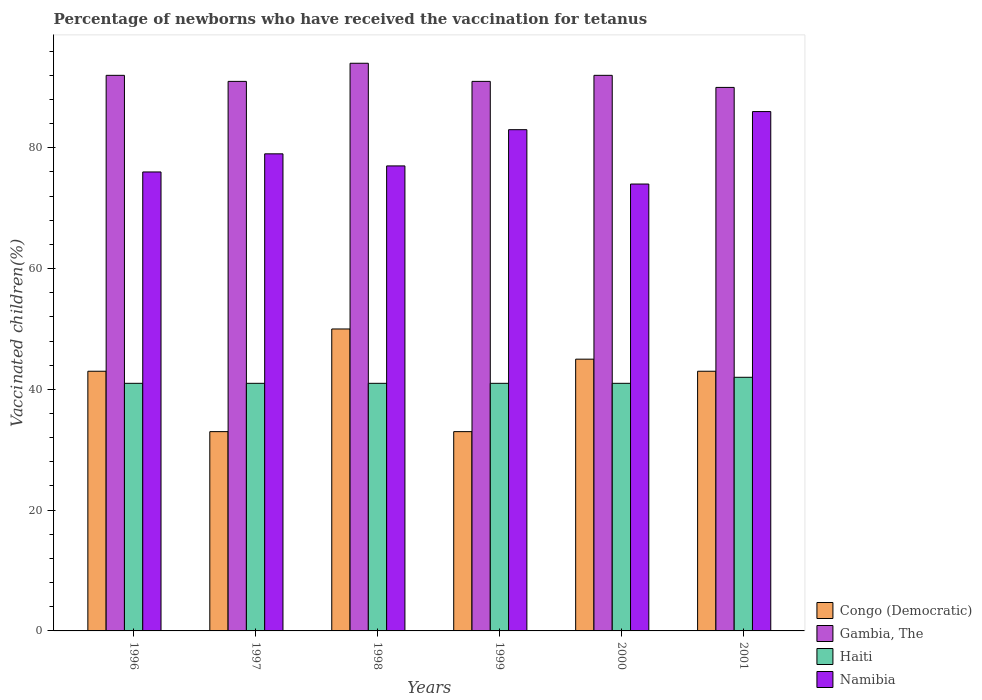How many different coloured bars are there?
Provide a short and direct response. 4. How many groups of bars are there?
Your answer should be compact. 6. What is the percentage of vaccinated children in Haiti in 1996?
Keep it short and to the point. 41. Across all years, what is the maximum percentage of vaccinated children in Haiti?
Make the answer very short. 42. Across all years, what is the minimum percentage of vaccinated children in Gambia, The?
Offer a terse response. 90. In which year was the percentage of vaccinated children in Haiti maximum?
Provide a short and direct response. 2001. What is the total percentage of vaccinated children in Haiti in the graph?
Ensure brevity in your answer.  247. What is the average percentage of vaccinated children in Haiti per year?
Ensure brevity in your answer.  41.17. In the year 1999, what is the difference between the percentage of vaccinated children in Haiti and percentage of vaccinated children in Namibia?
Keep it short and to the point. -42. In how many years, is the percentage of vaccinated children in Haiti greater than 80 %?
Offer a terse response. 0. What is the ratio of the percentage of vaccinated children in Haiti in 1999 to that in 2000?
Offer a terse response. 1. What is the difference between the highest and the lowest percentage of vaccinated children in Haiti?
Your answer should be compact. 1. What does the 1st bar from the left in 1996 represents?
Your answer should be compact. Congo (Democratic). What does the 4th bar from the right in 1999 represents?
Keep it short and to the point. Congo (Democratic). How many bars are there?
Your answer should be compact. 24. Are all the bars in the graph horizontal?
Offer a very short reply. No. How many years are there in the graph?
Make the answer very short. 6. Are the values on the major ticks of Y-axis written in scientific E-notation?
Offer a very short reply. No. Does the graph contain any zero values?
Offer a terse response. No. Does the graph contain grids?
Your answer should be compact. No. How many legend labels are there?
Ensure brevity in your answer.  4. What is the title of the graph?
Your answer should be very brief. Percentage of newborns who have received the vaccination for tetanus. Does "Eritrea" appear as one of the legend labels in the graph?
Offer a very short reply. No. What is the label or title of the X-axis?
Offer a terse response. Years. What is the label or title of the Y-axis?
Make the answer very short. Vaccinated children(%). What is the Vaccinated children(%) in Gambia, The in 1996?
Your answer should be very brief. 92. What is the Vaccinated children(%) in Congo (Democratic) in 1997?
Give a very brief answer. 33. What is the Vaccinated children(%) in Gambia, The in 1997?
Your response must be concise. 91. What is the Vaccinated children(%) in Namibia in 1997?
Make the answer very short. 79. What is the Vaccinated children(%) in Gambia, The in 1998?
Give a very brief answer. 94. What is the Vaccinated children(%) of Namibia in 1998?
Provide a short and direct response. 77. What is the Vaccinated children(%) of Congo (Democratic) in 1999?
Offer a very short reply. 33. What is the Vaccinated children(%) in Gambia, The in 1999?
Keep it short and to the point. 91. What is the Vaccinated children(%) of Haiti in 1999?
Your response must be concise. 41. What is the Vaccinated children(%) of Namibia in 1999?
Your answer should be compact. 83. What is the Vaccinated children(%) of Congo (Democratic) in 2000?
Offer a very short reply. 45. What is the Vaccinated children(%) of Gambia, The in 2000?
Offer a very short reply. 92. What is the Vaccinated children(%) in Gambia, The in 2001?
Offer a very short reply. 90. Across all years, what is the maximum Vaccinated children(%) in Congo (Democratic)?
Provide a succinct answer. 50. Across all years, what is the maximum Vaccinated children(%) of Gambia, The?
Your answer should be very brief. 94. Across all years, what is the maximum Vaccinated children(%) of Haiti?
Make the answer very short. 42. Across all years, what is the minimum Vaccinated children(%) in Congo (Democratic)?
Offer a terse response. 33. Across all years, what is the minimum Vaccinated children(%) in Gambia, The?
Your answer should be very brief. 90. Across all years, what is the minimum Vaccinated children(%) of Namibia?
Provide a short and direct response. 74. What is the total Vaccinated children(%) of Congo (Democratic) in the graph?
Your response must be concise. 247. What is the total Vaccinated children(%) in Gambia, The in the graph?
Provide a short and direct response. 550. What is the total Vaccinated children(%) in Haiti in the graph?
Offer a very short reply. 247. What is the total Vaccinated children(%) in Namibia in the graph?
Ensure brevity in your answer.  475. What is the difference between the Vaccinated children(%) in Gambia, The in 1996 and that in 1997?
Make the answer very short. 1. What is the difference between the Vaccinated children(%) in Haiti in 1996 and that in 1997?
Offer a very short reply. 0. What is the difference between the Vaccinated children(%) of Congo (Democratic) in 1996 and that in 1998?
Offer a very short reply. -7. What is the difference between the Vaccinated children(%) of Gambia, The in 1996 and that in 1999?
Offer a terse response. 1. What is the difference between the Vaccinated children(%) in Haiti in 1996 and that in 1999?
Offer a terse response. 0. What is the difference between the Vaccinated children(%) of Namibia in 1996 and that in 1999?
Keep it short and to the point. -7. What is the difference between the Vaccinated children(%) of Gambia, The in 1996 and that in 2000?
Your answer should be very brief. 0. What is the difference between the Vaccinated children(%) in Haiti in 1996 and that in 2000?
Offer a very short reply. 0. What is the difference between the Vaccinated children(%) in Namibia in 1996 and that in 2000?
Your answer should be compact. 2. What is the difference between the Vaccinated children(%) in Gambia, The in 1996 and that in 2001?
Make the answer very short. 2. What is the difference between the Vaccinated children(%) of Haiti in 1996 and that in 2001?
Your answer should be compact. -1. What is the difference between the Vaccinated children(%) of Gambia, The in 1997 and that in 1998?
Your response must be concise. -3. What is the difference between the Vaccinated children(%) in Haiti in 1997 and that in 1998?
Provide a succinct answer. 0. What is the difference between the Vaccinated children(%) in Congo (Democratic) in 1997 and that in 1999?
Keep it short and to the point. 0. What is the difference between the Vaccinated children(%) in Gambia, The in 1997 and that in 1999?
Make the answer very short. 0. What is the difference between the Vaccinated children(%) of Haiti in 1997 and that in 1999?
Ensure brevity in your answer.  0. What is the difference between the Vaccinated children(%) in Namibia in 1997 and that in 1999?
Provide a succinct answer. -4. What is the difference between the Vaccinated children(%) of Congo (Democratic) in 1997 and that in 2000?
Ensure brevity in your answer.  -12. What is the difference between the Vaccinated children(%) in Haiti in 1997 and that in 2000?
Provide a short and direct response. 0. What is the difference between the Vaccinated children(%) in Congo (Democratic) in 1997 and that in 2001?
Your answer should be very brief. -10. What is the difference between the Vaccinated children(%) in Haiti in 1997 and that in 2001?
Offer a very short reply. -1. What is the difference between the Vaccinated children(%) in Gambia, The in 1998 and that in 2000?
Provide a short and direct response. 2. What is the difference between the Vaccinated children(%) in Haiti in 1998 and that in 2001?
Give a very brief answer. -1. What is the difference between the Vaccinated children(%) of Namibia in 1998 and that in 2001?
Offer a terse response. -9. What is the difference between the Vaccinated children(%) of Congo (Democratic) in 1999 and that in 2000?
Offer a terse response. -12. What is the difference between the Vaccinated children(%) of Haiti in 1999 and that in 2000?
Your answer should be compact. 0. What is the difference between the Vaccinated children(%) of Namibia in 1999 and that in 2000?
Make the answer very short. 9. What is the difference between the Vaccinated children(%) in Congo (Democratic) in 2000 and that in 2001?
Ensure brevity in your answer.  2. What is the difference between the Vaccinated children(%) in Namibia in 2000 and that in 2001?
Provide a short and direct response. -12. What is the difference between the Vaccinated children(%) in Congo (Democratic) in 1996 and the Vaccinated children(%) in Gambia, The in 1997?
Offer a terse response. -48. What is the difference between the Vaccinated children(%) in Congo (Democratic) in 1996 and the Vaccinated children(%) in Namibia in 1997?
Your answer should be very brief. -36. What is the difference between the Vaccinated children(%) of Gambia, The in 1996 and the Vaccinated children(%) of Haiti in 1997?
Provide a succinct answer. 51. What is the difference between the Vaccinated children(%) in Gambia, The in 1996 and the Vaccinated children(%) in Namibia in 1997?
Make the answer very short. 13. What is the difference between the Vaccinated children(%) of Haiti in 1996 and the Vaccinated children(%) of Namibia in 1997?
Keep it short and to the point. -38. What is the difference between the Vaccinated children(%) in Congo (Democratic) in 1996 and the Vaccinated children(%) in Gambia, The in 1998?
Your response must be concise. -51. What is the difference between the Vaccinated children(%) of Congo (Democratic) in 1996 and the Vaccinated children(%) of Namibia in 1998?
Provide a short and direct response. -34. What is the difference between the Vaccinated children(%) in Gambia, The in 1996 and the Vaccinated children(%) in Namibia in 1998?
Give a very brief answer. 15. What is the difference between the Vaccinated children(%) of Haiti in 1996 and the Vaccinated children(%) of Namibia in 1998?
Give a very brief answer. -36. What is the difference between the Vaccinated children(%) in Congo (Democratic) in 1996 and the Vaccinated children(%) in Gambia, The in 1999?
Make the answer very short. -48. What is the difference between the Vaccinated children(%) of Congo (Democratic) in 1996 and the Vaccinated children(%) of Haiti in 1999?
Provide a succinct answer. 2. What is the difference between the Vaccinated children(%) of Haiti in 1996 and the Vaccinated children(%) of Namibia in 1999?
Ensure brevity in your answer.  -42. What is the difference between the Vaccinated children(%) in Congo (Democratic) in 1996 and the Vaccinated children(%) in Gambia, The in 2000?
Make the answer very short. -49. What is the difference between the Vaccinated children(%) of Congo (Democratic) in 1996 and the Vaccinated children(%) of Namibia in 2000?
Your response must be concise. -31. What is the difference between the Vaccinated children(%) in Gambia, The in 1996 and the Vaccinated children(%) in Namibia in 2000?
Keep it short and to the point. 18. What is the difference between the Vaccinated children(%) of Haiti in 1996 and the Vaccinated children(%) of Namibia in 2000?
Provide a short and direct response. -33. What is the difference between the Vaccinated children(%) of Congo (Democratic) in 1996 and the Vaccinated children(%) of Gambia, The in 2001?
Your response must be concise. -47. What is the difference between the Vaccinated children(%) in Congo (Democratic) in 1996 and the Vaccinated children(%) in Haiti in 2001?
Your response must be concise. 1. What is the difference between the Vaccinated children(%) in Congo (Democratic) in 1996 and the Vaccinated children(%) in Namibia in 2001?
Keep it short and to the point. -43. What is the difference between the Vaccinated children(%) of Gambia, The in 1996 and the Vaccinated children(%) of Haiti in 2001?
Offer a terse response. 50. What is the difference between the Vaccinated children(%) of Haiti in 1996 and the Vaccinated children(%) of Namibia in 2001?
Your answer should be very brief. -45. What is the difference between the Vaccinated children(%) in Congo (Democratic) in 1997 and the Vaccinated children(%) in Gambia, The in 1998?
Offer a very short reply. -61. What is the difference between the Vaccinated children(%) of Congo (Democratic) in 1997 and the Vaccinated children(%) of Haiti in 1998?
Your response must be concise. -8. What is the difference between the Vaccinated children(%) in Congo (Democratic) in 1997 and the Vaccinated children(%) in Namibia in 1998?
Offer a terse response. -44. What is the difference between the Vaccinated children(%) in Gambia, The in 1997 and the Vaccinated children(%) in Haiti in 1998?
Your answer should be very brief. 50. What is the difference between the Vaccinated children(%) of Haiti in 1997 and the Vaccinated children(%) of Namibia in 1998?
Offer a very short reply. -36. What is the difference between the Vaccinated children(%) in Congo (Democratic) in 1997 and the Vaccinated children(%) in Gambia, The in 1999?
Offer a very short reply. -58. What is the difference between the Vaccinated children(%) of Congo (Democratic) in 1997 and the Vaccinated children(%) of Haiti in 1999?
Offer a very short reply. -8. What is the difference between the Vaccinated children(%) of Haiti in 1997 and the Vaccinated children(%) of Namibia in 1999?
Provide a short and direct response. -42. What is the difference between the Vaccinated children(%) of Congo (Democratic) in 1997 and the Vaccinated children(%) of Gambia, The in 2000?
Provide a succinct answer. -59. What is the difference between the Vaccinated children(%) in Congo (Democratic) in 1997 and the Vaccinated children(%) in Namibia in 2000?
Your response must be concise. -41. What is the difference between the Vaccinated children(%) in Gambia, The in 1997 and the Vaccinated children(%) in Haiti in 2000?
Your response must be concise. 50. What is the difference between the Vaccinated children(%) of Haiti in 1997 and the Vaccinated children(%) of Namibia in 2000?
Offer a very short reply. -33. What is the difference between the Vaccinated children(%) of Congo (Democratic) in 1997 and the Vaccinated children(%) of Gambia, The in 2001?
Your response must be concise. -57. What is the difference between the Vaccinated children(%) of Congo (Democratic) in 1997 and the Vaccinated children(%) of Namibia in 2001?
Offer a very short reply. -53. What is the difference between the Vaccinated children(%) in Gambia, The in 1997 and the Vaccinated children(%) in Haiti in 2001?
Provide a succinct answer. 49. What is the difference between the Vaccinated children(%) in Haiti in 1997 and the Vaccinated children(%) in Namibia in 2001?
Keep it short and to the point. -45. What is the difference between the Vaccinated children(%) in Congo (Democratic) in 1998 and the Vaccinated children(%) in Gambia, The in 1999?
Make the answer very short. -41. What is the difference between the Vaccinated children(%) in Congo (Democratic) in 1998 and the Vaccinated children(%) in Haiti in 1999?
Offer a very short reply. 9. What is the difference between the Vaccinated children(%) of Congo (Democratic) in 1998 and the Vaccinated children(%) of Namibia in 1999?
Make the answer very short. -33. What is the difference between the Vaccinated children(%) of Gambia, The in 1998 and the Vaccinated children(%) of Haiti in 1999?
Ensure brevity in your answer.  53. What is the difference between the Vaccinated children(%) of Gambia, The in 1998 and the Vaccinated children(%) of Namibia in 1999?
Your answer should be very brief. 11. What is the difference between the Vaccinated children(%) in Haiti in 1998 and the Vaccinated children(%) in Namibia in 1999?
Your response must be concise. -42. What is the difference between the Vaccinated children(%) in Congo (Democratic) in 1998 and the Vaccinated children(%) in Gambia, The in 2000?
Make the answer very short. -42. What is the difference between the Vaccinated children(%) in Congo (Democratic) in 1998 and the Vaccinated children(%) in Haiti in 2000?
Keep it short and to the point. 9. What is the difference between the Vaccinated children(%) in Congo (Democratic) in 1998 and the Vaccinated children(%) in Namibia in 2000?
Offer a very short reply. -24. What is the difference between the Vaccinated children(%) of Gambia, The in 1998 and the Vaccinated children(%) of Namibia in 2000?
Keep it short and to the point. 20. What is the difference between the Vaccinated children(%) in Haiti in 1998 and the Vaccinated children(%) in Namibia in 2000?
Offer a terse response. -33. What is the difference between the Vaccinated children(%) in Congo (Democratic) in 1998 and the Vaccinated children(%) in Haiti in 2001?
Offer a very short reply. 8. What is the difference between the Vaccinated children(%) in Congo (Democratic) in 1998 and the Vaccinated children(%) in Namibia in 2001?
Your answer should be very brief. -36. What is the difference between the Vaccinated children(%) of Gambia, The in 1998 and the Vaccinated children(%) of Haiti in 2001?
Keep it short and to the point. 52. What is the difference between the Vaccinated children(%) in Haiti in 1998 and the Vaccinated children(%) in Namibia in 2001?
Make the answer very short. -45. What is the difference between the Vaccinated children(%) of Congo (Democratic) in 1999 and the Vaccinated children(%) of Gambia, The in 2000?
Offer a terse response. -59. What is the difference between the Vaccinated children(%) in Congo (Democratic) in 1999 and the Vaccinated children(%) in Namibia in 2000?
Offer a terse response. -41. What is the difference between the Vaccinated children(%) in Gambia, The in 1999 and the Vaccinated children(%) in Haiti in 2000?
Make the answer very short. 50. What is the difference between the Vaccinated children(%) in Haiti in 1999 and the Vaccinated children(%) in Namibia in 2000?
Keep it short and to the point. -33. What is the difference between the Vaccinated children(%) in Congo (Democratic) in 1999 and the Vaccinated children(%) in Gambia, The in 2001?
Give a very brief answer. -57. What is the difference between the Vaccinated children(%) of Congo (Democratic) in 1999 and the Vaccinated children(%) of Namibia in 2001?
Offer a terse response. -53. What is the difference between the Vaccinated children(%) of Gambia, The in 1999 and the Vaccinated children(%) of Haiti in 2001?
Ensure brevity in your answer.  49. What is the difference between the Vaccinated children(%) of Haiti in 1999 and the Vaccinated children(%) of Namibia in 2001?
Provide a short and direct response. -45. What is the difference between the Vaccinated children(%) of Congo (Democratic) in 2000 and the Vaccinated children(%) of Gambia, The in 2001?
Provide a succinct answer. -45. What is the difference between the Vaccinated children(%) of Congo (Democratic) in 2000 and the Vaccinated children(%) of Haiti in 2001?
Provide a short and direct response. 3. What is the difference between the Vaccinated children(%) of Congo (Democratic) in 2000 and the Vaccinated children(%) of Namibia in 2001?
Offer a very short reply. -41. What is the difference between the Vaccinated children(%) of Haiti in 2000 and the Vaccinated children(%) of Namibia in 2001?
Provide a succinct answer. -45. What is the average Vaccinated children(%) of Congo (Democratic) per year?
Your answer should be very brief. 41.17. What is the average Vaccinated children(%) in Gambia, The per year?
Keep it short and to the point. 91.67. What is the average Vaccinated children(%) of Haiti per year?
Ensure brevity in your answer.  41.17. What is the average Vaccinated children(%) in Namibia per year?
Offer a terse response. 79.17. In the year 1996, what is the difference between the Vaccinated children(%) of Congo (Democratic) and Vaccinated children(%) of Gambia, The?
Offer a terse response. -49. In the year 1996, what is the difference between the Vaccinated children(%) in Congo (Democratic) and Vaccinated children(%) in Namibia?
Offer a very short reply. -33. In the year 1996, what is the difference between the Vaccinated children(%) in Gambia, The and Vaccinated children(%) in Haiti?
Your answer should be compact. 51. In the year 1996, what is the difference between the Vaccinated children(%) of Gambia, The and Vaccinated children(%) of Namibia?
Keep it short and to the point. 16. In the year 1996, what is the difference between the Vaccinated children(%) of Haiti and Vaccinated children(%) of Namibia?
Your answer should be compact. -35. In the year 1997, what is the difference between the Vaccinated children(%) of Congo (Democratic) and Vaccinated children(%) of Gambia, The?
Ensure brevity in your answer.  -58. In the year 1997, what is the difference between the Vaccinated children(%) of Congo (Democratic) and Vaccinated children(%) of Namibia?
Your response must be concise. -46. In the year 1997, what is the difference between the Vaccinated children(%) of Gambia, The and Vaccinated children(%) of Haiti?
Your response must be concise. 50. In the year 1997, what is the difference between the Vaccinated children(%) in Gambia, The and Vaccinated children(%) in Namibia?
Give a very brief answer. 12. In the year 1997, what is the difference between the Vaccinated children(%) in Haiti and Vaccinated children(%) in Namibia?
Provide a succinct answer. -38. In the year 1998, what is the difference between the Vaccinated children(%) in Congo (Democratic) and Vaccinated children(%) in Gambia, The?
Your answer should be very brief. -44. In the year 1998, what is the difference between the Vaccinated children(%) in Haiti and Vaccinated children(%) in Namibia?
Offer a terse response. -36. In the year 1999, what is the difference between the Vaccinated children(%) of Congo (Democratic) and Vaccinated children(%) of Gambia, The?
Keep it short and to the point. -58. In the year 1999, what is the difference between the Vaccinated children(%) of Congo (Democratic) and Vaccinated children(%) of Haiti?
Ensure brevity in your answer.  -8. In the year 1999, what is the difference between the Vaccinated children(%) in Congo (Democratic) and Vaccinated children(%) in Namibia?
Offer a terse response. -50. In the year 1999, what is the difference between the Vaccinated children(%) of Gambia, The and Vaccinated children(%) of Haiti?
Offer a terse response. 50. In the year 1999, what is the difference between the Vaccinated children(%) of Gambia, The and Vaccinated children(%) of Namibia?
Your answer should be compact. 8. In the year 1999, what is the difference between the Vaccinated children(%) in Haiti and Vaccinated children(%) in Namibia?
Provide a succinct answer. -42. In the year 2000, what is the difference between the Vaccinated children(%) in Congo (Democratic) and Vaccinated children(%) in Gambia, The?
Your answer should be very brief. -47. In the year 2000, what is the difference between the Vaccinated children(%) of Congo (Democratic) and Vaccinated children(%) of Namibia?
Offer a terse response. -29. In the year 2000, what is the difference between the Vaccinated children(%) of Gambia, The and Vaccinated children(%) of Namibia?
Keep it short and to the point. 18. In the year 2000, what is the difference between the Vaccinated children(%) of Haiti and Vaccinated children(%) of Namibia?
Offer a terse response. -33. In the year 2001, what is the difference between the Vaccinated children(%) of Congo (Democratic) and Vaccinated children(%) of Gambia, The?
Your answer should be compact. -47. In the year 2001, what is the difference between the Vaccinated children(%) of Congo (Democratic) and Vaccinated children(%) of Namibia?
Your response must be concise. -43. In the year 2001, what is the difference between the Vaccinated children(%) of Gambia, The and Vaccinated children(%) of Haiti?
Keep it short and to the point. 48. In the year 2001, what is the difference between the Vaccinated children(%) of Haiti and Vaccinated children(%) of Namibia?
Ensure brevity in your answer.  -44. What is the ratio of the Vaccinated children(%) of Congo (Democratic) in 1996 to that in 1997?
Your response must be concise. 1.3. What is the ratio of the Vaccinated children(%) in Gambia, The in 1996 to that in 1997?
Keep it short and to the point. 1.01. What is the ratio of the Vaccinated children(%) in Congo (Democratic) in 1996 to that in 1998?
Offer a terse response. 0.86. What is the ratio of the Vaccinated children(%) of Gambia, The in 1996 to that in 1998?
Ensure brevity in your answer.  0.98. What is the ratio of the Vaccinated children(%) of Haiti in 1996 to that in 1998?
Offer a very short reply. 1. What is the ratio of the Vaccinated children(%) in Congo (Democratic) in 1996 to that in 1999?
Provide a succinct answer. 1.3. What is the ratio of the Vaccinated children(%) in Gambia, The in 1996 to that in 1999?
Your answer should be compact. 1.01. What is the ratio of the Vaccinated children(%) of Namibia in 1996 to that in 1999?
Provide a short and direct response. 0.92. What is the ratio of the Vaccinated children(%) of Congo (Democratic) in 1996 to that in 2000?
Your answer should be compact. 0.96. What is the ratio of the Vaccinated children(%) of Haiti in 1996 to that in 2000?
Offer a terse response. 1. What is the ratio of the Vaccinated children(%) in Namibia in 1996 to that in 2000?
Make the answer very short. 1.03. What is the ratio of the Vaccinated children(%) of Congo (Democratic) in 1996 to that in 2001?
Offer a very short reply. 1. What is the ratio of the Vaccinated children(%) of Gambia, The in 1996 to that in 2001?
Your answer should be compact. 1.02. What is the ratio of the Vaccinated children(%) in Haiti in 1996 to that in 2001?
Provide a succinct answer. 0.98. What is the ratio of the Vaccinated children(%) in Namibia in 1996 to that in 2001?
Provide a short and direct response. 0.88. What is the ratio of the Vaccinated children(%) of Congo (Democratic) in 1997 to that in 1998?
Ensure brevity in your answer.  0.66. What is the ratio of the Vaccinated children(%) in Gambia, The in 1997 to that in 1998?
Make the answer very short. 0.97. What is the ratio of the Vaccinated children(%) in Haiti in 1997 to that in 1998?
Make the answer very short. 1. What is the ratio of the Vaccinated children(%) of Namibia in 1997 to that in 1998?
Make the answer very short. 1.03. What is the ratio of the Vaccinated children(%) in Congo (Democratic) in 1997 to that in 1999?
Ensure brevity in your answer.  1. What is the ratio of the Vaccinated children(%) of Gambia, The in 1997 to that in 1999?
Provide a succinct answer. 1. What is the ratio of the Vaccinated children(%) of Haiti in 1997 to that in 1999?
Offer a terse response. 1. What is the ratio of the Vaccinated children(%) of Namibia in 1997 to that in 1999?
Offer a terse response. 0.95. What is the ratio of the Vaccinated children(%) of Congo (Democratic) in 1997 to that in 2000?
Your answer should be compact. 0.73. What is the ratio of the Vaccinated children(%) in Gambia, The in 1997 to that in 2000?
Make the answer very short. 0.99. What is the ratio of the Vaccinated children(%) in Namibia in 1997 to that in 2000?
Offer a terse response. 1.07. What is the ratio of the Vaccinated children(%) of Congo (Democratic) in 1997 to that in 2001?
Give a very brief answer. 0.77. What is the ratio of the Vaccinated children(%) in Gambia, The in 1997 to that in 2001?
Offer a terse response. 1.01. What is the ratio of the Vaccinated children(%) of Haiti in 1997 to that in 2001?
Provide a succinct answer. 0.98. What is the ratio of the Vaccinated children(%) of Namibia in 1997 to that in 2001?
Ensure brevity in your answer.  0.92. What is the ratio of the Vaccinated children(%) of Congo (Democratic) in 1998 to that in 1999?
Your answer should be compact. 1.52. What is the ratio of the Vaccinated children(%) in Gambia, The in 1998 to that in 1999?
Provide a short and direct response. 1.03. What is the ratio of the Vaccinated children(%) in Haiti in 1998 to that in 1999?
Make the answer very short. 1. What is the ratio of the Vaccinated children(%) in Namibia in 1998 to that in 1999?
Provide a succinct answer. 0.93. What is the ratio of the Vaccinated children(%) of Gambia, The in 1998 to that in 2000?
Your answer should be compact. 1.02. What is the ratio of the Vaccinated children(%) of Namibia in 1998 to that in 2000?
Your response must be concise. 1.04. What is the ratio of the Vaccinated children(%) of Congo (Democratic) in 1998 to that in 2001?
Offer a terse response. 1.16. What is the ratio of the Vaccinated children(%) of Gambia, The in 1998 to that in 2001?
Make the answer very short. 1.04. What is the ratio of the Vaccinated children(%) of Haiti in 1998 to that in 2001?
Your response must be concise. 0.98. What is the ratio of the Vaccinated children(%) in Namibia in 1998 to that in 2001?
Your answer should be very brief. 0.9. What is the ratio of the Vaccinated children(%) in Congo (Democratic) in 1999 to that in 2000?
Keep it short and to the point. 0.73. What is the ratio of the Vaccinated children(%) in Haiti in 1999 to that in 2000?
Keep it short and to the point. 1. What is the ratio of the Vaccinated children(%) of Namibia in 1999 to that in 2000?
Your answer should be compact. 1.12. What is the ratio of the Vaccinated children(%) in Congo (Democratic) in 1999 to that in 2001?
Offer a very short reply. 0.77. What is the ratio of the Vaccinated children(%) in Gambia, The in 1999 to that in 2001?
Your answer should be very brief. 1.01. What is the ratio of the Vaccinated children(%) of Haiti in 1999 to that in 2001?
Ensure brevity in your answer.  0.98. What is the ratio of the Vaccinated children(%) in Namibia in 1999 to that in 2001?
Your response must be concise. 0.97. What is the ratio of the Vaccinated children(%) of Congo (Democratic) in 2000 to that in 2001?
Keep it short and to the point. 1.05. What is the ratio of the Vaccinated children(%) of Gambia, The in 2000 to that in 2001?
Make the answer very short. 1.02. What is the ratio of the Vaccinated children(%) of Haiti in 2000 to that in 2001?
Give a very brief answer. 0.98. What is the ratio of the Vaccinated children(%) in Namibia in 2000 to that in 2001?
Give a very brief answer. 0.86. What is the difference between the highest and the second highest Vaccinated children(%) of Congo (Democratic)?
Offer a terse response. 5. What is the difference between the highest and the second highest Vaccinated children(%) in Haiti?
Give a very brief answer. 1. What is the difference between the highest and the second highest Vaccinated children(%) in Namibia?
Give a very brief answer. 3. 